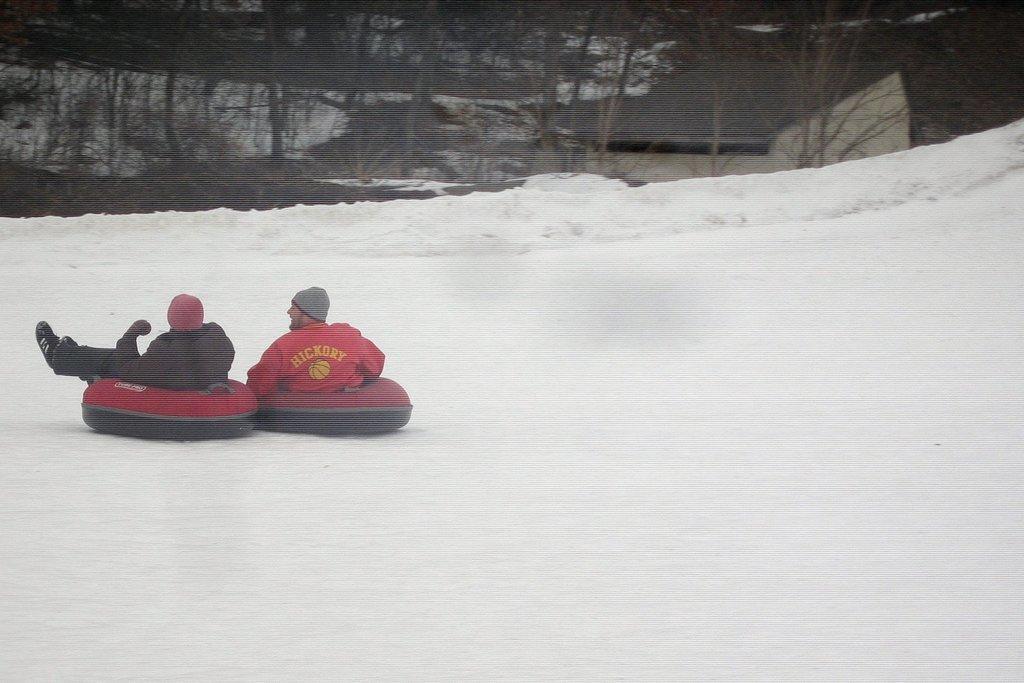In one or two sentences, can you explain what this image depicts? In this image I can see the snow. On the left side there are two persons wearing jackets, caps on the heads and sitting on the snow tubes facing towards the back side. In the background there are many trees. 